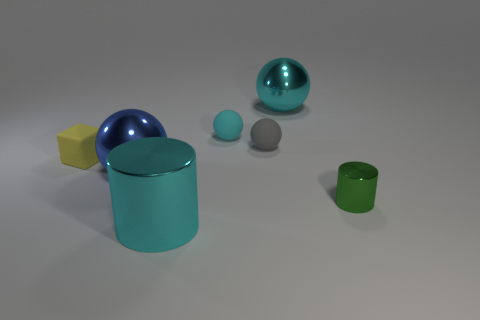Subtract all small cyan rubber balls. How many balls are left? 3 Subtract all blocks. How many objects are left? 6 Add 1 tiny gray balls. How many objects exist? 8 Subtract all cyan cylinders. How many cylinders are left? 1 Subtract all purple spheres. Subtract all gray cylinders. How many spheres are left? 4 Subtract all cyan spheres. How many purple blocks are left? 0 Subtract all large green metallic balls. Subtract all small gray matte objects. How many objects are left? 6 Add 2 tiny cyan matte objects. How many tiny cyan matte objects are left? 3 Add 7 blue metallic balls. How many blue metallic balls exist? 8 Subtract 0 green cubes. How many objects are left? 7 